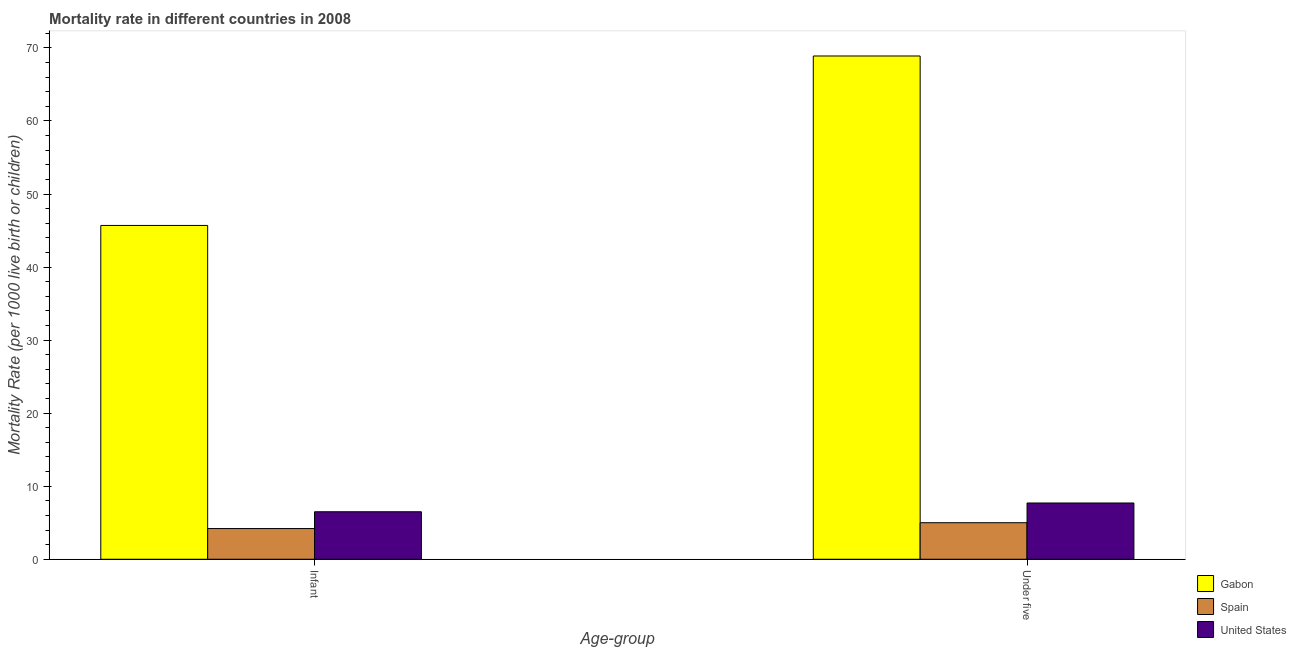How many different coloured bars are there?
Make the answer very short. 3. Are the number of bars on each tick of the X-axis equal?
Keep it short and to the point. Yes. How many bars are there on the 1st tick from the left?
Offer a very short reply. 3. What is the label of the 1st group of bars from the left?
Offer a very short reply. Infant. What is the under-5 mortality rate in Gabon?
Provide a succinct answer. 68.9. Across all countries, what is the maximum under-5 mortality rate?
Provide a short and direct response. 68.9. Across all countries, what is the minimum infant mortality rate?
Give a very brief answer. 4.2. In which country was the infant mortality rate maximum?
Provide a succinct answer. Gabon. In which country was the under-5 mortality rate minimum?
Make the answer very short. Spain. What is the total infant mortality rate in the graph?
Provide a short and direct response. 56.4. What is the average infant mortality rate per country?
Your answer should be compact. 18.8. What is the difference between the under-5 mortality rate and infant mortality rate in United States?
Make the answer very short. 1.2. In how many countries, is the infant mortality rate greater than 68 ?
Your response must be concise. 0. What is the ratio of the under-5 mortality rate in Gabon to that in United States?
Your answer should be compact. 8.95. What does the 1st bar from the left in Under five represents?
Your answer should be very brief. Gabon. What does the 1st bar from the right in Under five represents?
Keep it short and to the point. United States. How many bars are there?
Offer a very short reply. 6. Are all the bars in the graph horizontal?
Provide a succinct answer. No. Does the graph contain grids?
Make the answer very short. No. Where does the legend appear in the graph?
Ensure brevity in your answer.  Bottom right. How many legend labels are there?
Provide a succinct answer. 3. What is the title of the graph?
Your answer should be very brief. Mortality rate in different countries in 2008. What is the label or title of the X-axis?
Keep it short and to the point. Age-group. What is the label or title of the Y-axis?
Your answer should be compact. Mortality Rate (per 1000 live birth or children). What is the Mortality Rate (per 1000 live birth or children) of Gabon in Infant?
Provide a short and direct response. 45.7. What is the Mortality Rate (per 1000 live birth or children) in Spain in Infant?
Your answer should be very brief. 4.2. What is the Mortality Rate (per 1000 live birth or children) in Gabon in Under five?
Offer a very short reply. 68.9. What is the Mortality Rate (per 1000 live birth or children) of Spain in Under five?
Your answer should be very brief. 5. Across all Age-group, what is the maximum Mortality Rate (per 1000 live birth or children) in Gabon?
Your answer should be compact. 68.9. Across all Age-group, what is the maximum Mortality Rate (per 1000 live birth or children) of Spain?
Keep it short and to the point. 5. Across all Age-group, what is the maximum Mortality Rate (per 1000 live birth or children) of United States?
Keep it short and to the point. 7.7. Across all Age-group, what is the minimum Mortality Rate (per 1000 live birth or children) in Gabon?
Your answer should be compact. 45.7. What is the total Mortality Rate (per 1000 live birth or children) in Gabon in the graph?
Provide a succinct answer. 114.6. What is the total Mortality Rate (per 1000 live birth or children) of Spain in the graph?
Your response must be concise. 9.2. What is the total Mortality Rate (per 1000 live birth or children) of United States in the graph?
Offer a very short reply. 14.2. What is the difference between the Mortality Rate (per 1000 live birth or children) in Gabon in Infant and that in Under five?
Make the answer very short. -23.2. What is the difference between the Mortality Rate (per 1000 live birth or children) in Gabon in Infant and the Mortality Rate (per 1000 live birth or children) in Spain in Under five?
Your response must be concise. 40.7. What is the difference between the Mortality Rate (per 1000 live birth or children) of Gabon in Infant and the Mortality Rate (per 1000 live birth or children) of United States in Under five?
Make the answer very short. 38. What is the average Mortality Rate (per 1000 live birth or children) in Gabon per Age-group?
Ensure brevity in your answer.  57.3. What is the average Mortality Rate (per 1000 live birth or children) of Spain per Age-group?
Your answer should be very brief. 4.6. What is the average Mortality Rate (per 1000 live birth or children) in United States per Age-group?
Keep it short and to the point. 7.1. What is the difference between the Mortality Rate (per 1000 live birth or children) of Gabon and Mortality Rate (per 1000 live birth or children) of Spain in Infant?
Your answer should be compact. 41.5. What is the difference between the Mortality Rate (per 1000 live birth or children) in Gabon and Mortality Rate (per 1000 live birth or children) in United States in Infant?
Your response must be concise. 39.2. What is the difference between the Mortality Rate (per 1000 live birth or children) of Gabon and Mortality Rate (per 1000 live birth or children) of Spain in Under five?
Make the answer very short. 63.9. What is the difference between the Mortality Rate (per 1000 live birth or children) in Gabon and Mortality Rate (per 1000 live birth or children) in United States in Under five?
Give a very brief answer. 61.2. What is the ratio of the Mortality Rate (per 1000 live birth or children) of Gabon in Infant to that in Under five?
Provide a succinct answer. 0.66. What is the ratio of the Mortality Rate (per 1000 live birth or children) in Spain in Infant to that in Under five?
Provide a succinct answer. 0.84. What is the ratio of the Mortality Rate (per 1000 live birth or children) of United States in Infant to that in Under five?
Ensure brevity in your answer.  0.84. What is the difference between the highest and the second highest Mortality Rate (per 1000 live birth or children) in Gabon?
Keep it short and to the point. 23.2. What is the difference between the highest and the lowest Mortality Rate (per 1000 live birth or children) in Gabon?
Ensure brevity in your answer.  23.2. What is the difference between the highest and the lowest Mortality Rate (per 1000 live birth or children) of United States?
Keep it short and to the point. 1.2. 